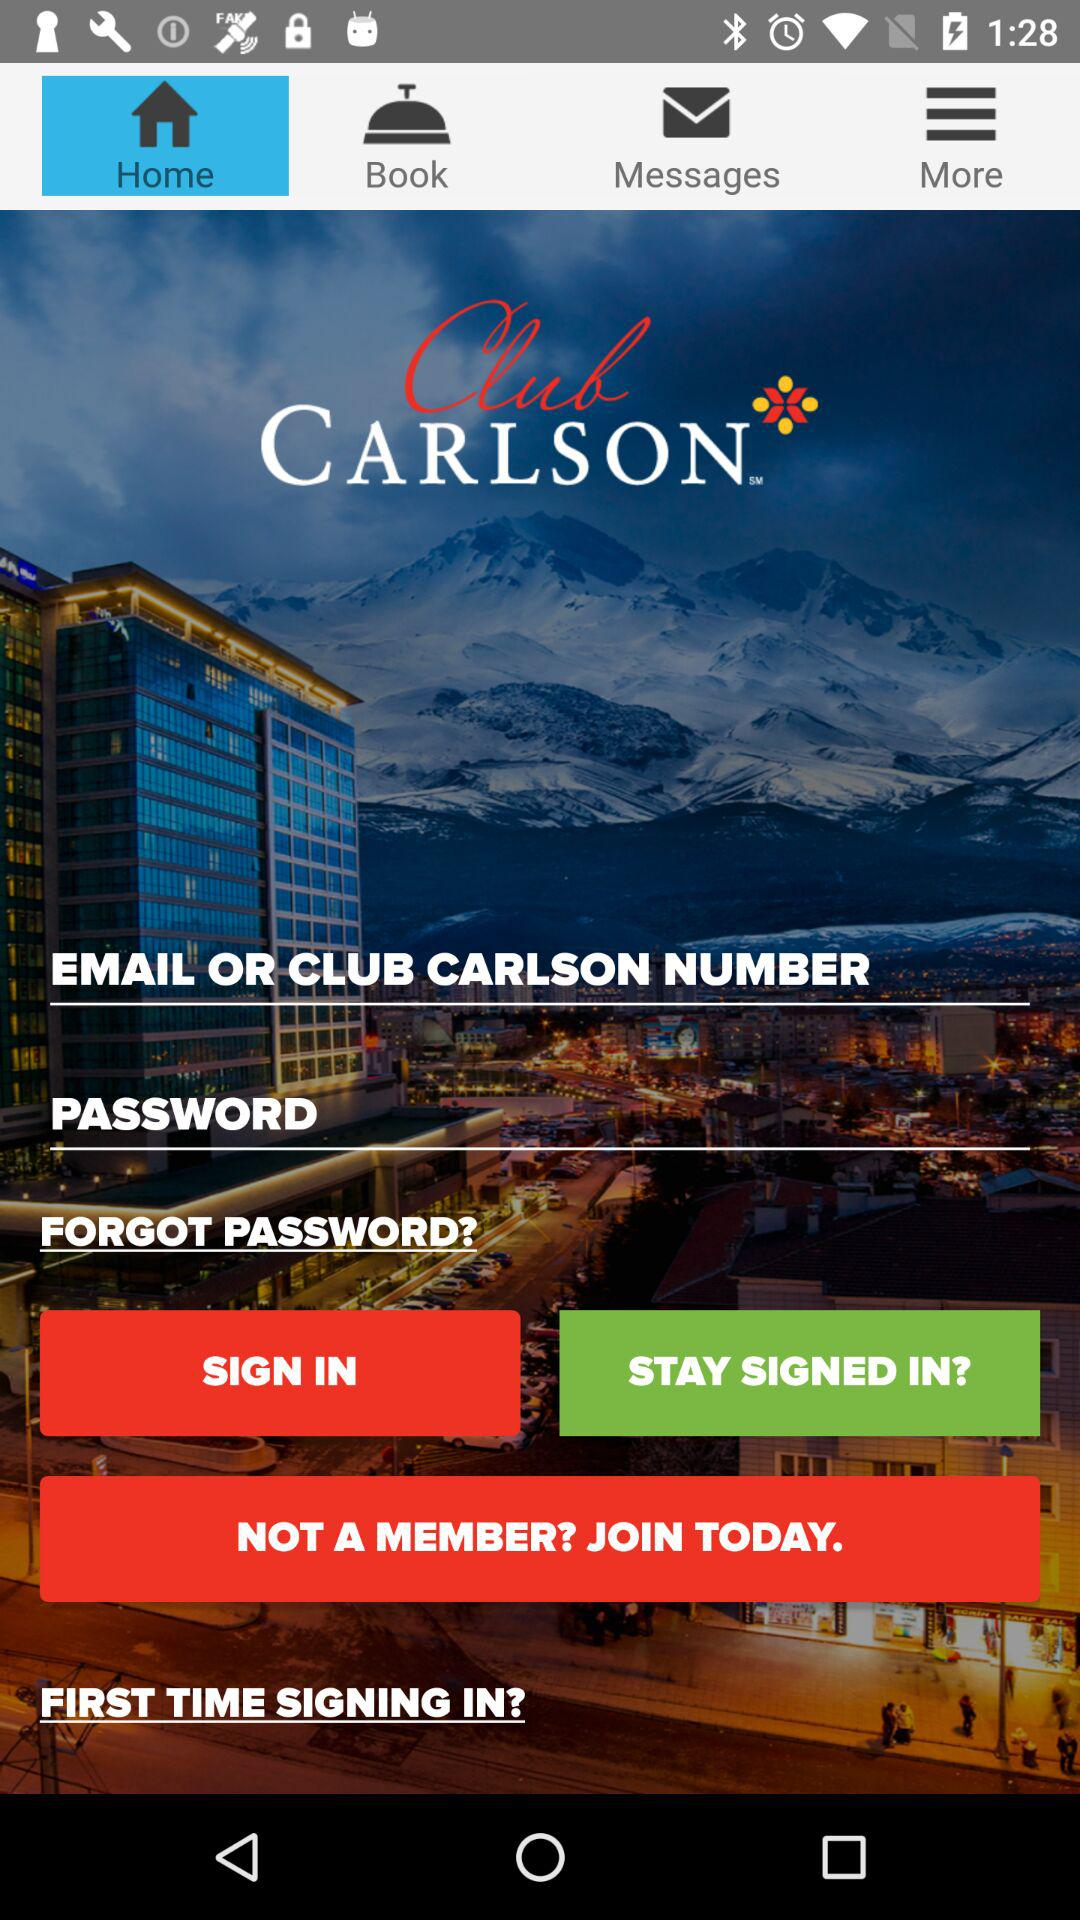Which tab has been selected? The selected tab is "Home". 